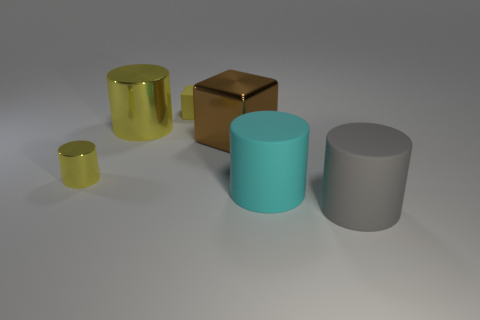The large metallic object that is the same shape as the small yellow rubber object is what color?
Your answer should be very brief. Brown. Is there anything else that is the same color as the tiny cylinder?
Your answer should be very brief. Yes. How many other objects are there of the same material as the tiny cube?
Your answer should be very brief. 2. What size is the gray thing?
Your answer should be compact. Large. Is there a big brown metallic thing of the same shape as the large yellow shiny object?
Make the answer very short. No. How many objects are shiny cylinders or small yellow blocks that are behind the big gray cylinder?
Your answer should be compact. 3. There is a metal cylinder that is in front of the large yellow object; what color is it?
Offer a very short reply. Yellow. Do the yellow metal thing in front of the brown shiny block and the yellow metallic thing behind the large shiny cube have the same size?
Offer a very short reply. No. Is there another brown block of the same size as the shiny block?
Offer a terse response. No. How many metallic blocks are in front of the large object behind the large block?
Provide a short and direct response. 1. 